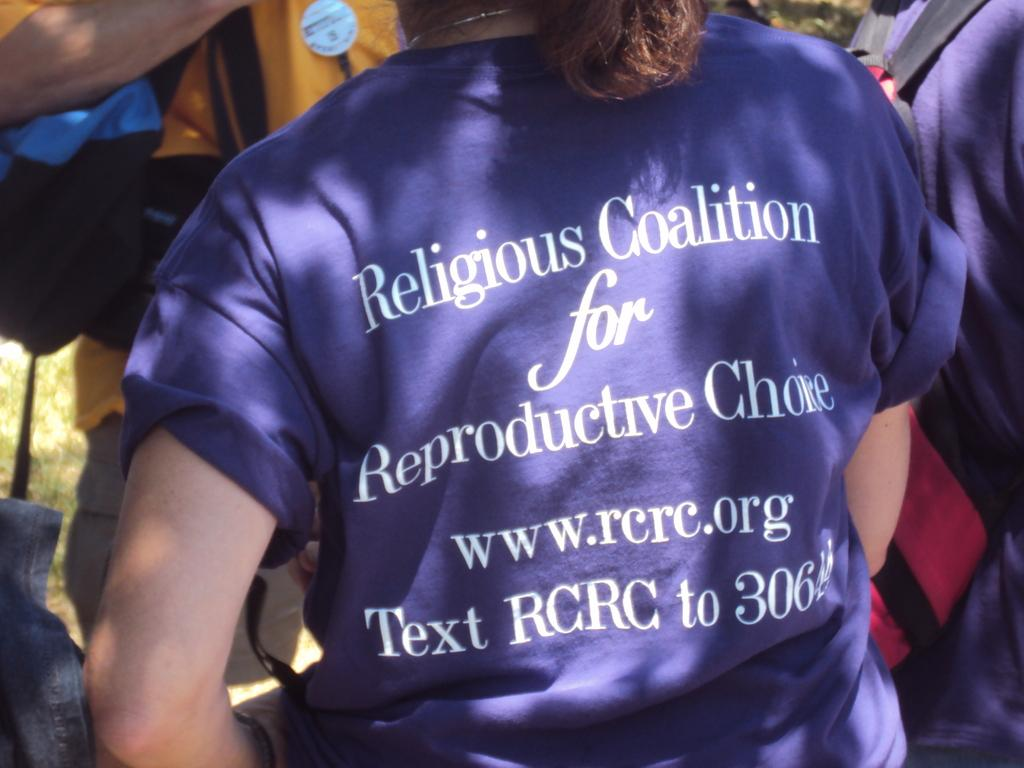<image>
Write a terse but informative summary of the picture. A girl wearing a purple shirt that says Religious Coalition for Reproductive Choice. 